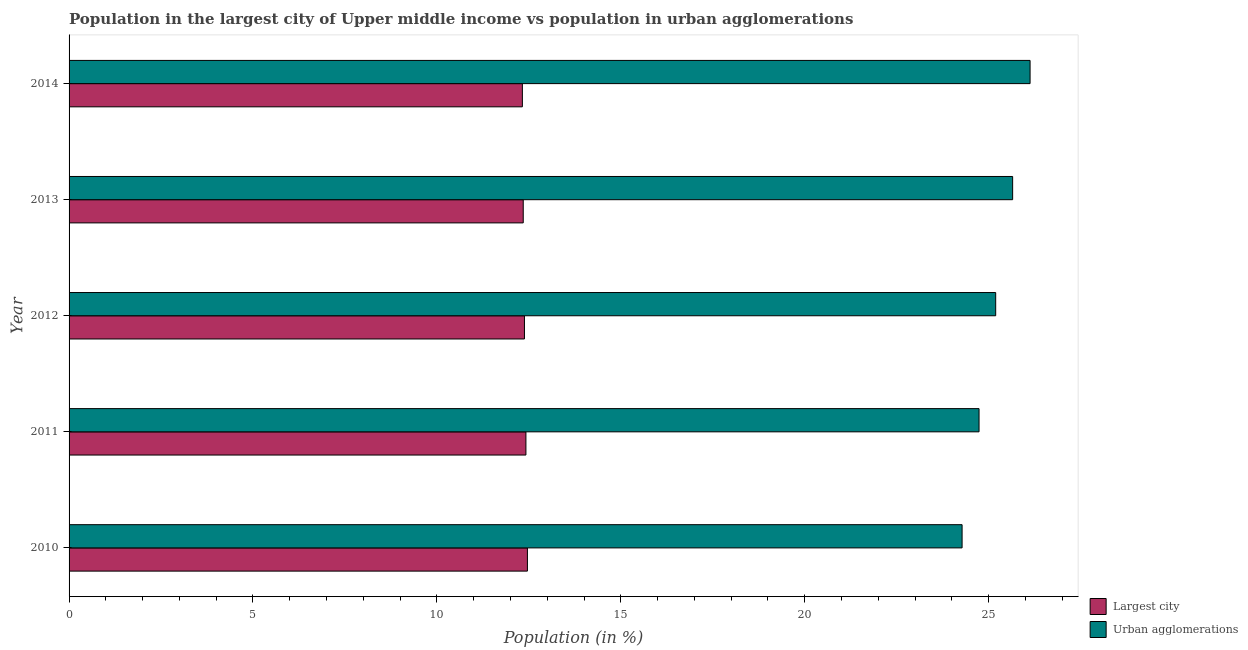Are the number of bars per tick equal to the number of legend labels?
Make the answer very short. Yes. What is the label of the 5th group of bars from the top?
Make the answer very short. 2010. In how many cases, is the number of bars for a given year not equal to the number of legend labels?
Provide a short and direct response. 0. What is the population in the largest city in 2014?
Ensure brevity in your answer.  12.32. Across all years, what is the maximum population in urban agglomerations?
Ensure brevity in your answer.  26.13. Across all years, what is the minimum population in the largest city?
Offer a very short reply. 12.32. In which year was the population in the largest city maximum?
Offer a terse response. 2010. In which year was the population in urban agglomerations minimum?
Offer a terse response. 2010. What is the total population in urban agglomerations in the graph?
Your response must be concise. 125.99. What is the difference between the population in the largest city in 2010 and that in 2012?
Ensure brevity in your answer.  0.08. What is the difference between the population in the largest city in 2013 and the population in urban agglomerations in 2012?
Give a very brief answer. -12.85. What is the average population in urban agglomerations per year?
Your answer should be very brief. 25.2. In the year 2011, what is the difference between the population in the largest city and population in urban agglomerations?
Your answer should be very brief. -12.32. What is the ratio of the population in the largest city in 2010 to that in 2012?
Offer a very short reply. 1.01. Is the population in urban agglomerations in 2010 less than that in 2013?
Keep it short and to the point. Yes. What is the difference between the highest and the second highest population in urban agglomerations?
Keep it short and to the point. 0.47. What is the difference between the highest and the lowest population in the largest city?
Make the answer very short. 0.14. Is the sum of the population in urban agglomerations in 2010 and 2014 greater than the maximum population in the largest city across all years?
Your response must be concise. Yes. What does the 2nd bar from the top in 2010 represents?
Your response must be concise. Largest city. What does the 2nd bar from the bottom in 2012 represents?
Make the answer very short. Urban agglomerations. What is the difference between two consecutive major ticks on the X-axis?
Keep it short and to the point. 5. Does the graph contain any zero values?
Make the answer very short. No. How many legend labels are there?
Your answer should be very brief. 2. How are the legend labels stacked?
Keep it short and to the point. Vertical. What is the title of the graph?
Provide a succinct answer. Population in the largest city of Upper middle income vs population in urban agglomerations. What is the label or title of the X-axis?
Your response must be concise. Population (in %). What is the label or title of the Y-axis?
Your answer should be very brief. Year. What is the Population (in %) in Largest city in 2010?
Make the answer very short. 12.46. What is the Population (in %) of Urban agglomerations in 2010?
Offer a terse response. 24.28. What is the Population (in %) in Largest city in 2011?
Offer a terse response. 12.42. What is the Population (in %) in Urban agglomerations in 2011?
Your answer should be compact. 24.74. What is the Population (in %) of Largest city in 2012?
Keep it short and to the point. 12.38. What is the Population (in %) in Urban agglomerations in 2012?
Provide a succinct answer. 25.19. What is the Population (in %) in Largest city in 2013?
Keep it short and to the point. 12.35. What is the Population (in %) of Urban agglomerations in 2013?
Provide a short and direct response. 25.65. What is the Population (in %) of Largest city in 2014?
Provide a succinct answer. 12.32. What is the Population (in %) in Urban agglomerations in 2014?
Offer a terse response. 26.13. Across all years, what is the maximum Population (in %) in Largest city?
Offer a terse response. 12.46. Across all years, what is the maximum Population (in %) of Urban agglomerations?
Provide a succinct answer. 26.13. Across all years, what is the minimum Population (in %) of Largest city?
Give a very brief answer. 12.32. Across all years, what is the minimum Population (in %) of Urban agglomerations?
Your response must be concise. 24.28. What is the total Population (in %) of Largest city in the graph?
Provide a short and direct response. 61.94. What is the total Population (in %) in Urban agglomerations in the graph?
Give a very brief answer. 125.99. What is the difference between the Population (in %) of Largest city in 2010 and that in 2011?
Offer a terse response. 0.04. What is the difference between the Population (in %) in Urban agglomerations in 2010 and that in 2011?
Provide a short and direct response. -0.46. What is the difference between the Population (in %) of Largest city in 2010 and that in 2012?
Your answer should be compact. 0.08. What is the difference between the Population (in %) of Urban agglomerations in 2010 and that in 2012?
Make the answer very short. -0.91. What is the difference between the Population (in %) in Largest city in 2010 and that in 2013?
Ensure brevity in your answer.  0.11. What is the difference between the Population (in %) of Urban agglomerations in 2010 and that in 2013?
Keep it short and to the point. -1.37. What is the difference between the Population (in %) of Largest city in 2010 and that in 2014?
Provide a short and direct response. 0.14. What is the difference between the Population (in %) of Urban agglomerations in 2010 and that in 2014?
Give a very brief answer. -1.85. What is the difference between the Population (in %) in Largest city in 2011 and that in 2012?
Provide a short and direct response. 0.04. What is the difference between the Population (in %) of Urban agglomerations in 2011 and that in 2012?
Provide a short and direct response. -0.45. What is the difference between the Population (in %) in Largest city in 2011 and that in 2013?
Make the answer very short. 0.07. What is the difference between the Population (in %) of Urban agglomerations in 2011 and that in 2013?
Offer a terse response. -0.91. What is the difference between the Population (in %) of Largest city in 2011 and that in 2014?
Your answer should be very brief. 0.1. What is the difference between the Population (in %) of Urban agglomerations in 2011 and that in 2014?
Keep it short and to the point. -1.39. What is the difference between the Population (in %) of Largest city in 2012 and that in 2013?
Ensure brevity in your answer.  0.03. What is the difference between the Population (in %) of Urban agglomerations in 2012 and that in 2013?
Give a very brief answer. -0.46. What is the difference between the Population (in %) in Largest city in 2012 and that in 2014?
Give a very brief answer. 0.06. What is the difference between the Population (in %) in Urban agglomerations in 2012 and that in 2014?
Provide a short and direct response. -0.94. What is the difference between the Population (in %) of Largest city in 2013 and that in 2014?
Keep it short and to the point. 0.02. What is the difference between the Population (in %) of Urban agglomerations in 2013 and that in 2014?
Your answer should be compact. -0.47. What is the difference between the Population (in %) of Largest city in 2010 and the Population (in %) of Urban agglomerations in 2011?
Give a very brief answer. -12.28. What is the difference between the Population (in %) of Largest city in 2010 and the Population (in %) of Urban agglomerations in 2012?
Your answer should be very brief. -12.73. What is the difference between the Population (in %) in Largest city in 2010 and the Population (in %) in Urban agglomerations in 2013?
Offer a terse response. -13.19. What is the difference between the Population (in %) in Largest city in 2010 and the Population (in %) in Urban agglomerations in 2014?
Your answer should be very brief. -13.67. What is the difference between the Population (in %) in Largest city in 2011 and the Population (in %) in Urban agglomerations in 2012?
Keep it short and to the point. -12.77. What is the difference between the Population (in %) in Largest city in 2011 and the Population (in %) in Urban agglomerations in 2013?
Your answer should be compact. -13.23. What is the difference between the Population (in %) in Largest city in 2011 and the Population (in %) in Urban agglomerations in 2014?
Offer a terse response. -13.71. What is the difference between the Population (in %) of Largest city in 2012 and the Population (in %) of Urban agglomerations in 2013?
Your answer should be very brief. -13.27. What is the difference between the Population (in %) of Largest city in 2012 and the Population (in %) of Urban agglomerations in 2014?
Offer a terse response. -13.75. What is the difference between the Population (in %) in Largest city in 2013 and the Population (in %) in Urban agglomerations in 2014?
Ensure brevity in your answer.  -13.78. What is the average Population (in %) in Largest city per year?
Offer a very short reply. 12.39. What is the average Population (in %) in Urban agglomerations per year?
Provide a short and direct response. 25.2. In the year 2010, what is the difference between the Population (in %) in Largest city and Population (in %) in Urban agglomerations?
Offer a very short reply. -11.82. In the year 2011, what is the difference between the Population (in %) of Largest city and Population (in %) of Urban agglomerations?
Provide a succinct answer. -12.32. In the year 2012, what is the difference between the Population (in %) in Largest city and Population (in %) in Urban agglomerations?
Provide a short and direct response. -12.81. In the year 2013, what is the difference between the Population (in %) in Largest city and Population (in %) in Urban agglomerations?
Your answer should be compact. -13.31. In the year 2014, what is the difference between the Population (in %) in Largest city and Population (in %) in Urban agglomerations?
Give a very brief answer. -13.8. What is the ratio of the Population (in %) in Urban agglomerations in 2010 to that in 2011?
Ensure brevity in your answer.  0.98. What is the ratio of the Population (in %) of Largest city in 2010 to that in 2012?
Your answer should be very brief. 1.01. What is the ratio of the Population (in %) of Urban agglomerations in 2010 to that in 2012?
Keep it short and to the point. 0.96. What is the ratio of the Population (in %) in Largest city in 2010 to that in 2013?
Provide a succinct answer. 1.01. What is the ratio of the Population (in %) in Urban agglomerations in 2010 to that in 2013?
Your answer should be very brief. 0.95. What is the ratio of the Population (in %) in Largest city in 2010 to that in 2014?
Your answer should be compact. 1.01. What is the ratio of the Population (in %) in Urban agglomerations in 2010 to that in 2014?
Keep it short and to the point. 0.93. What is the ratio of the Population (in %) of Largest city in 2011 to that in 2012?
Keep it short and to the point. 1. What is the ratio of the Population (in %) of Urban agglomerations in 2011 to that in 2012?
Make the answer very short. 0.98. What is the ratio of the Population (in %) in Largest city in 2011 to that in 2013?
Keep it short and to the point. 1.01. What is the ratio of the Population (in %) in Urban agglomerations in 2011 to that in 2013?
Offer a terse response. 0.96. What is the ratio of the Population (in %) in Largest city in 2011 to that in 2014?
Ensure brevity in your answer.  1.01. What is the ratio of the Population (in %) in Urban agglomerations in 2011 to that in 2014?
Offer a terse response. 0.95. What is the ratio of the Population (in %) of Largest city in 2012 to that in 2013?
Provide a succinct answer. 1. What is the ratio of the Population (in %) in Largest city in 2012 to that in 2014?
Offer a terse response. 1. What is the ratio of the Population (in %) of Urban agglomerations in 2012 to that in 2014?
Offer a terse response. 0.96. What is the ratio of the Population (in %) in Urban agglomerations in 2013 to that in 2014?
Your answer should be very brief. 0.98. What is the difference between the highest and the second highest Population (in %) in Largest city?
Make the answer very short. 0.04. What is the difference between the highest and the second highest Population (in %) in Urban agglomerations?
Give a very brief answer. 0.47. What is the difference between the highest and the lowest Population (in %) of Largest city?
Your answer should be very brief. 0.14. What is the difference between the highest and the lowest Population (in %) in Urban agglomerations?
Your answer should be very brief. 1.85. 